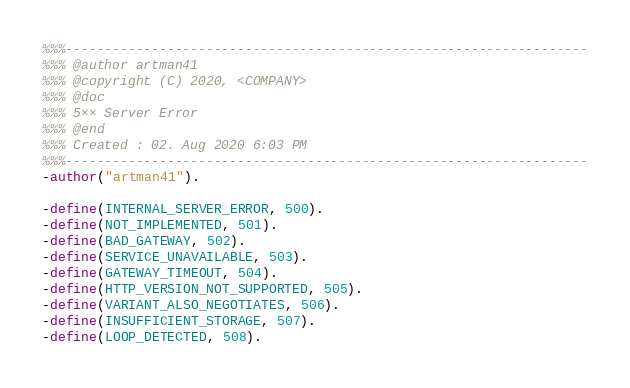<code> <loc_0><loc_0><loc_500><loc_500><_Erlang_>%%%-------------------------------------------------------------------
%%% @author artman41
%%% @copyright (C) 2020, <COMPANY>
%%% @doc
%%% 5×× Server Error
%%% @end
%%% Created : 02. Aug 2020 6:03 PM
%%%-------------------------------------------------------------------
-author("artman41").

-define(INTERNAL_SERVER_ERROR, 500).
-define(NOT_IMPLEMENTED, 501).
-define(BAD_GATEWAY, 502).
-define(SERVICE_UNAVAILABLE, 503).
-define(GATEWAY_TIMEOUT, 504).
-define(HTTP_VERSION_NOT_SUPPORTED, 505).
-define(VARIANT_ALSO_NEGOTIATES, 506).
-define(INSUFFICIENT_STORAGE, 507).
-define(LOOP_DETECTED, 508).</code> 